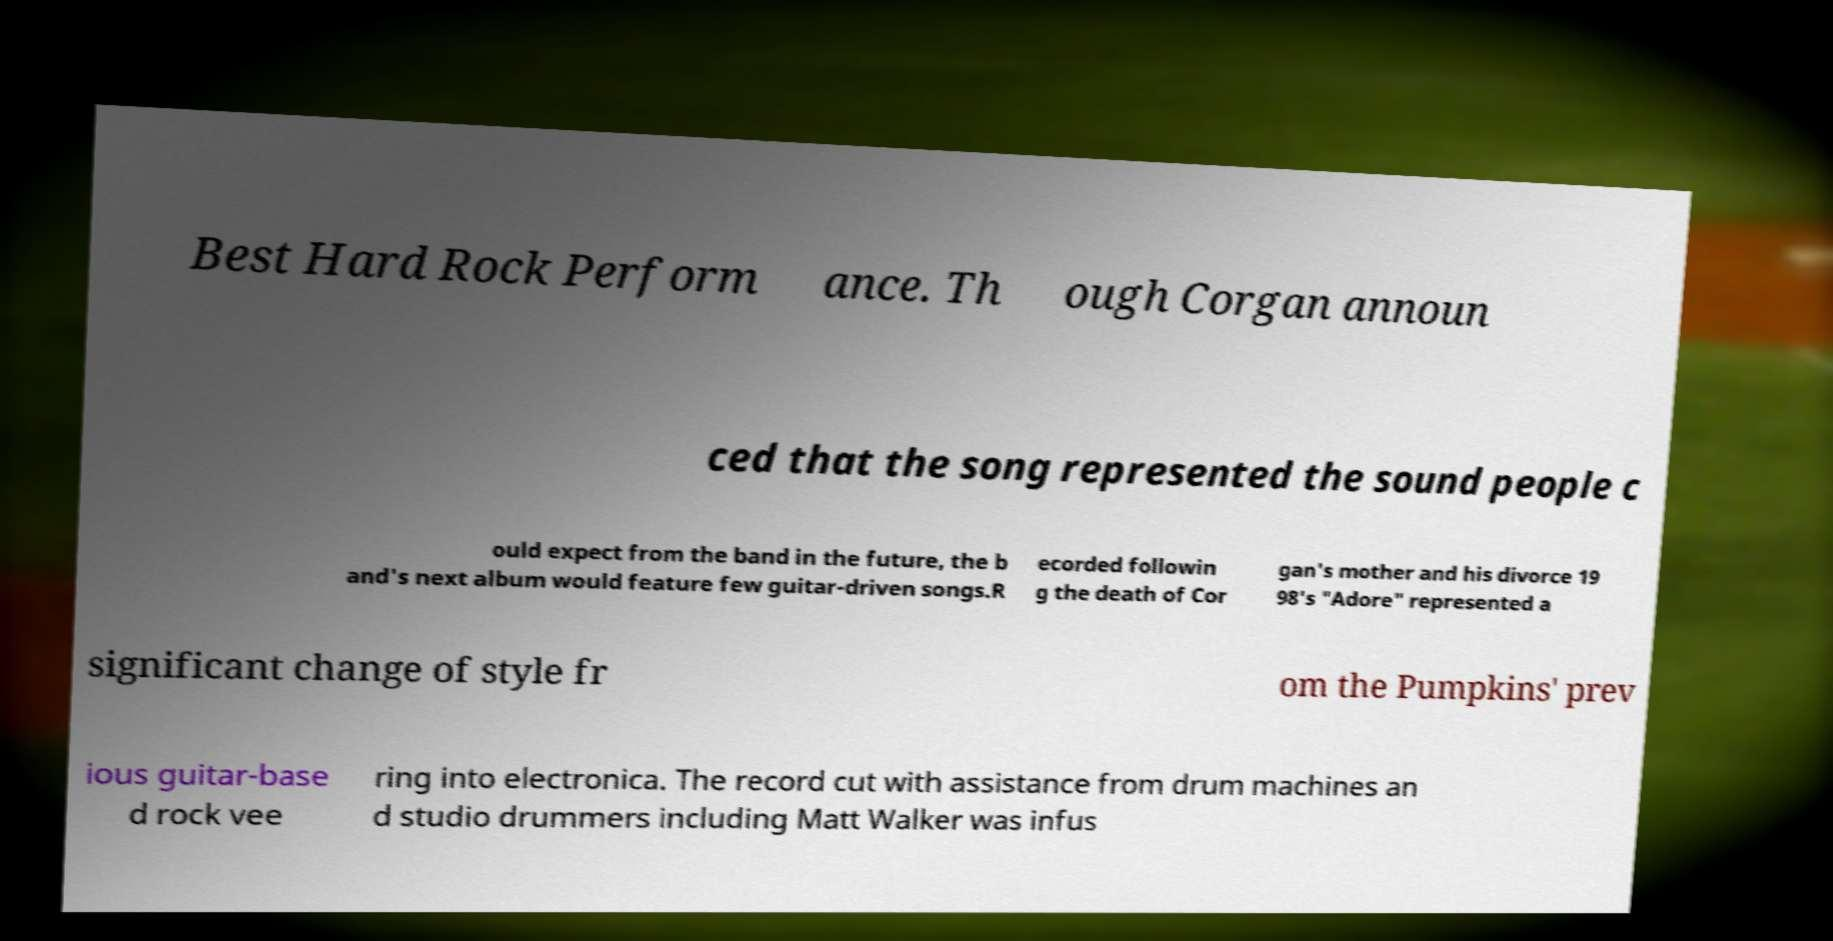For documentation purposes, I need the text within this image transcribed. Could you provide that? Best Hard Rock Perform ance. Th ough Corgan announ ced that the song represented the sound people c ould expect from the band in the future, the b and's next album would feature few guitar-driven songs.R ecorded followin g the death of Cor gan's mother and his divorce 19 98's "Adore" represented a significant change of style fr om the Pumpkins' prev ious guitar-base d rock vee ring into electronica. The record cut with assistance from drum machines an d studio drummers including Matt Walker was infus 